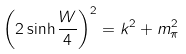Convert formula to latex. <formula><loc_0><loc_0><loc_500><loc_500>\left ( 2 \sinh \frac { W } { 4 } \right ) ^ { 2 } = k ^ { 2 } + m _ { \pi } ^ { 2 }</formula> 